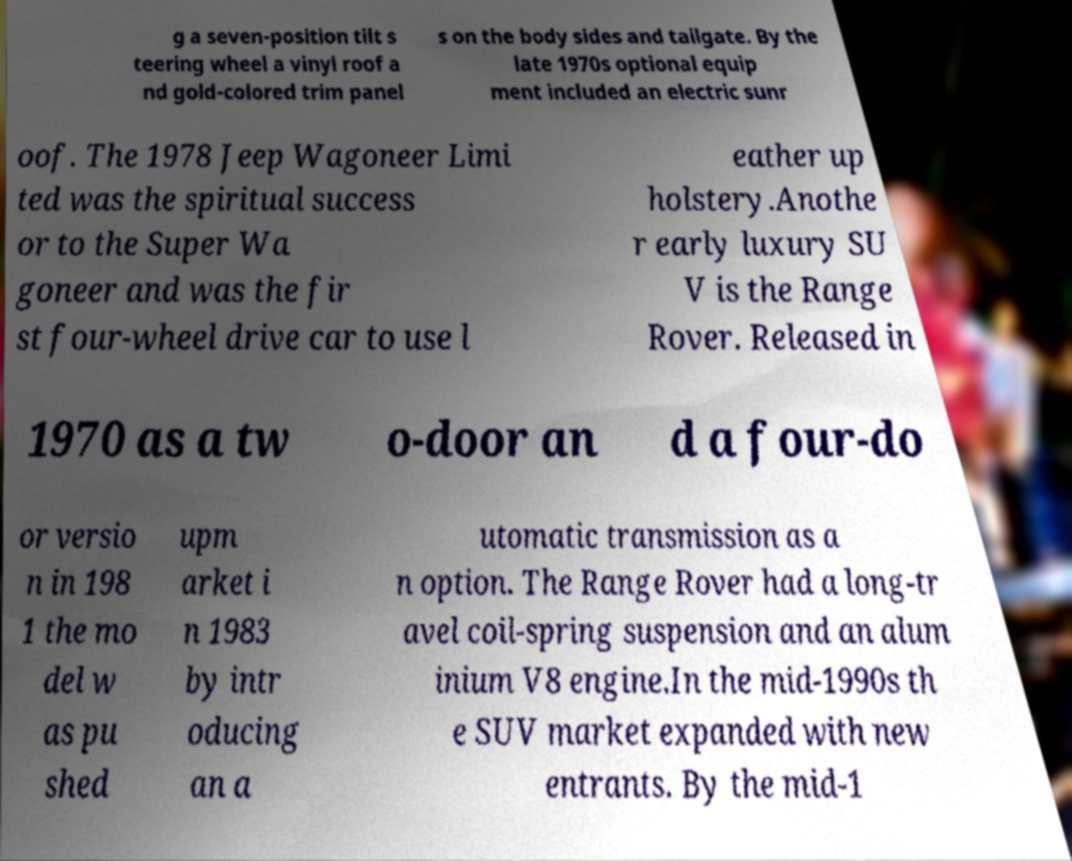Please identify and transcribe the text found in this image. g a seven-position tilt s teering wheel a vinyl roof a nd gold-colored trim panel s on the body sides and tailgate. By the late 1970s optional equip ment included an electric sunr oof. The 1978 Jeep Wagoneer Limi ted was the spiritual success or to the Super Wa goneer and was the fir st four-wheel drive car to use l eather up holstery.Anothe r early luxury SU V is the Range Rover. Released in 1970 as a tw o-door an d a four-do or versio n in 198 1 the mo del w as pu shed upm arket i n 1983 by intr oducing an a utomatic transmission as a n option. The Range Rover had a long-tr avel coil-spring suspension and an alum inium V8 engine.In the mid-1990s th e SUV market expanded with new entrants. By the mid-1 